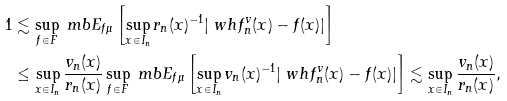<formula> <loc_0><loc_0><loc_500><loc_500>1 & \lesssim \sup _ { f \in F } \ m b E _ { f \mu } \left [ \sup _ { x \in I _ { n } } r _ { n } ( x ) ^ { - 1 } | \ w h f _ { n } ^ { v } ( x ) - f ( x ) | \right ] \\ & \leq \sup _ { x \in I _ { n } } \frac { v _ { n } ( x ) } { r _ { n } ( x ) } \sup _ { f \in F } \ m b E _ { f \mu } \left [ \sup _ { x \in I _ { n } } v _ { n } ( x ) ^ { - 1 } | \ w h f _ { n } ^ { v } ( x ) - f ( x ) | \right ] \lesssim \sup _ { x \in I _ { n } } \frac { v _ { n } ( x ) } { r _ { n } ( x ) } ,</formula> 